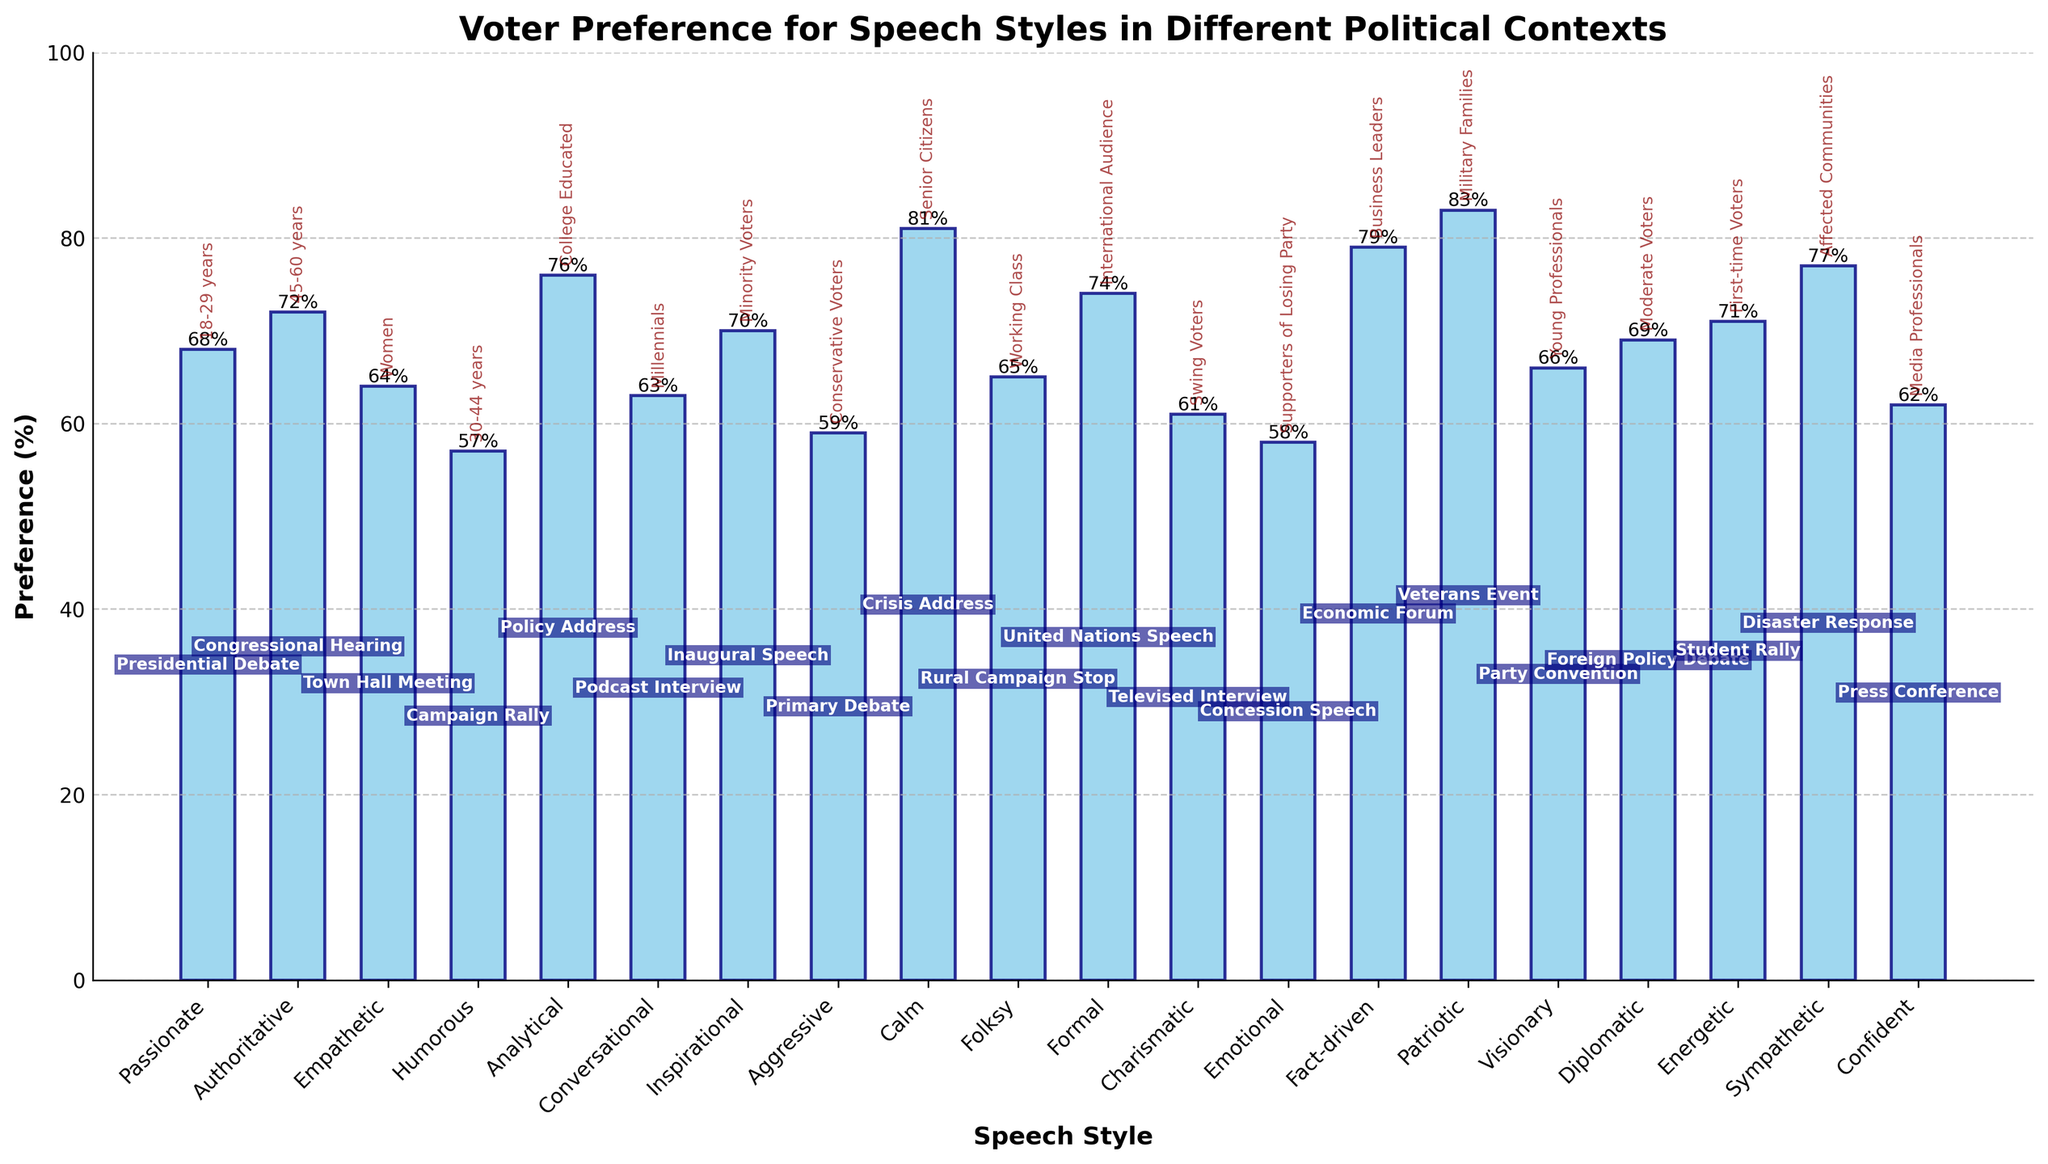What is the average preference percentage for speech styles in all contexts? Sum all preference percentages: 68 + 72 + 64 + 57 + 76 + 63 + 70 + 59 + 81 + 65 + 74 + 61 + 58 + 79 + 83 + 66 + 69 + 71 + 77 + 62 = 1355. There are 20 speech styles, so the average is 1355 / 20 = 67.75
Answer: 67.75 Which demographic has the highest preference percentage, and for what speech style? Scan all demographic labels and their corresponding percentages in the visual. The highest value is 83% for "Military Families" preferring "Patriotic" style.
Answer: Military Families, Patriotic Which speech style is least preferred, and by which demographic? Look for the shortest bar in the chart to identify the lowest preference. "Humorous" style has the lowest preference at 57%, preferred by "30-44 years" demographic.
Answer: Humorous, 30-44 years Which speech style has a preference percentage within the range of 65% to 70%? Identify bars whose heights fall between 65% and 70%. "Inspirational" (70%), "Folksy" (65%), and "Visionary" (66%) fall within this range.
Answer: Inspirational, Folksy, Visionary What is the difference in preference percentage between the “Analytical” and “Sympathetic” speech styles? Refer to the values for "Analytical" and "Sympathetic". Analytical has 76%, and Sympathetic has 77%. Difference is 77 - 76 = 1.
Answer: 1 Which political context corresponds to the highest voter preference, and what is that percentage? Identify the tallest bar which is "Patriotic". It corresponds to the "Veterans Event" context at 83%.
Answer: Veterans Event, 83% How does the preference for "Energetic" speech style compare with "Calm"? "Energetic" has a preference of 71%, while "Calm" has 81%. 81% is higher than 71%.
Answer: Calm > Energetic How many speech styles have a voter preference of 70% or higher? Count the number of bars with heights of 70% or greater: "Calm" (81%), "Analytical" (76%), "Patriotic" (83%), "Fact-driven" (79%), "Sympathetic" (77%), "Authoritative" (72%), "Energetic" (71%), "Inspirational" (70%). There are 8 such bars.
Answer: 8 What political context is preferred by the "Millennials" demographic, and what percentage does it have? Find the bar labeled “Millennials” and identify its context and percentage. "Millennials" prefer "Podcast Interview" at 63%.
Answer: Podcast Interview, 63 Compare the preferences for the "Authoritative" and "Conversational" speech styles. Which one is higher and by how much? Compare the "Authoritative" style (72%) with the "Conversational" style (63%). The difference is 72 - 63 = 9. "Authoritative" is higher by 9%.
Answer: Authoritative by 9 